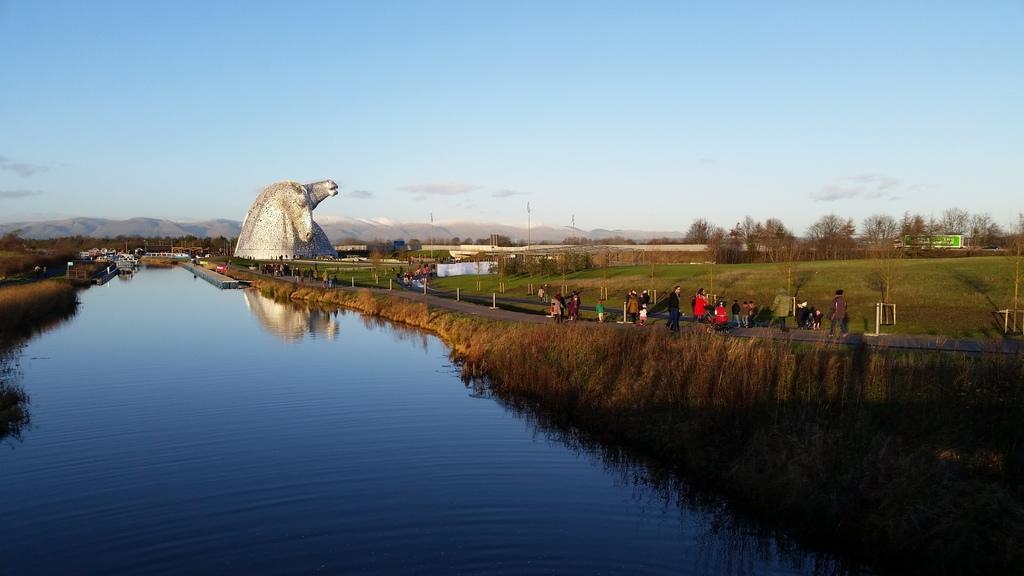Could you give a brief overview of what you see in this image? In this image we can see a river. On the right side of the image, we can see grass, trees, board, poles and people. In the background, there is an architecture. At the top of the image, we can see the blue color sky. 